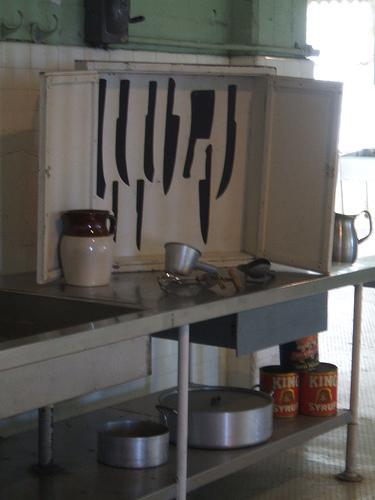Which one of these vegetables is used in the manufacture of the item in the cans? corn 